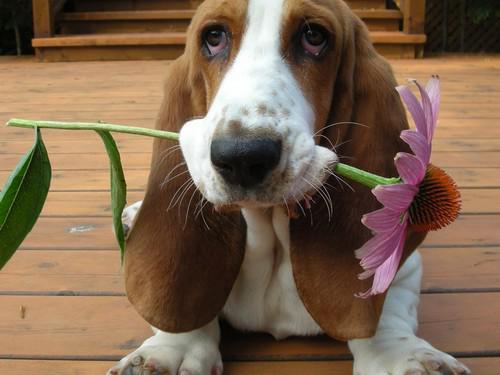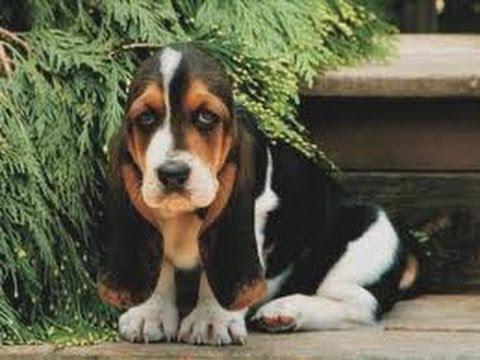The first image is the image on the left, the second image is the image on the right. Given the left and right images, does the statement "There are 4 or more dogs, and one of them is being held up by a human." hold true? Answer yes or no. No. The first image is the image on the left, the second image is the image on the right. Assess this claim about the two images: "At least three puppies are positioned directly next to each other in one photograph.". Correct or not? Answer yes or no. No. 